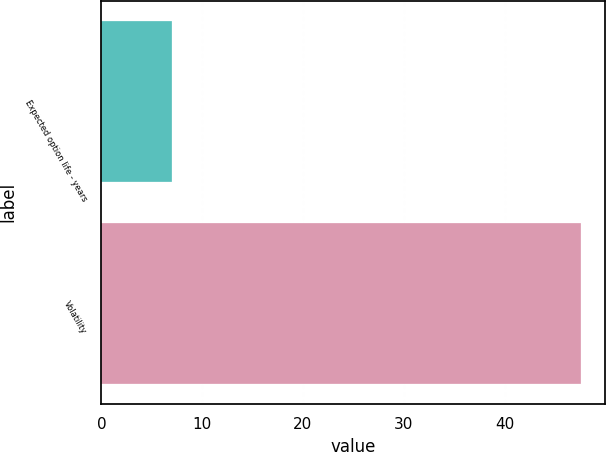Convert chart to OTSL. <chart><loc_0><loc_0><loc_500><loc_500><bar_chart><fcel>Expected option life - years<fcel>Volatility<nl><fcel>7<fcel>47.6<nl></chart> 